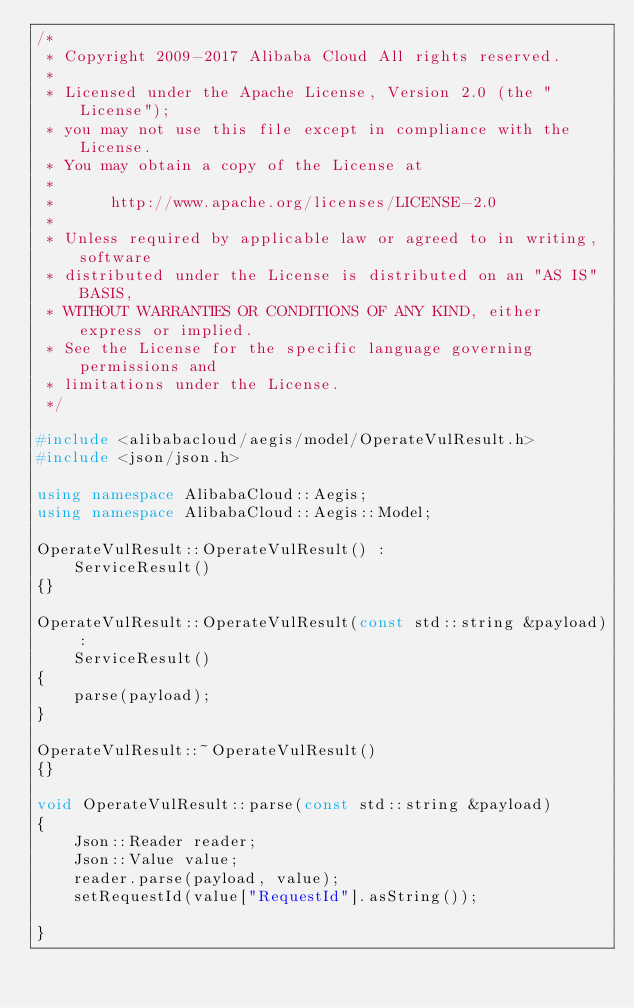Convert code to text. <code><loc_0><loc_0><loc_500><loc_500><_C++_>/*
 * Copyright 2009-2017 Alibaba Cloud All rights reserved.
 * 
 * Licensed under the Apache License, Version 2.0 (the "License");
 * you may not use this file except in compliance with the License.
 * You may obtain a copy of the License at
 * 
 *      http://www.apache.org/licenses/LICENSE-2.0
 * 
 * Unless required by applicable law or agreed to in writing, software
 * distributed under the License is distributed on an "AS IS" BASIS,
 * WITHOUT WARRANTIES OR CONDITIONS OF ANY KIND, either express or implied.
 * See the License for the specific language governing permissions and
 * limitations under the License.
 */

#include <alibabacloud/aegis/model/OperateVulResult.h>
#include <json/json.h>

using namespace AlibabaCloud::Aegis;
using namespace AlibabaCloud::Aegis::Model;

OperateVulResult::OperateVulResult() :
	ServiceResult()
{}

OperateVulResult::OperateVulResult(const std::string &payload) :
	ServiceResult()
{
	parse(payload);
}

OperateVulResult::~OperateVulResult()
{}

void OperateVulResult::parse(const std::string &payload)
{
	Json::Reader reader;
	Json::Value value;
	reader.parse(payload, value);
	setRequestId(value["RequestId"].asString());

}

</code> 